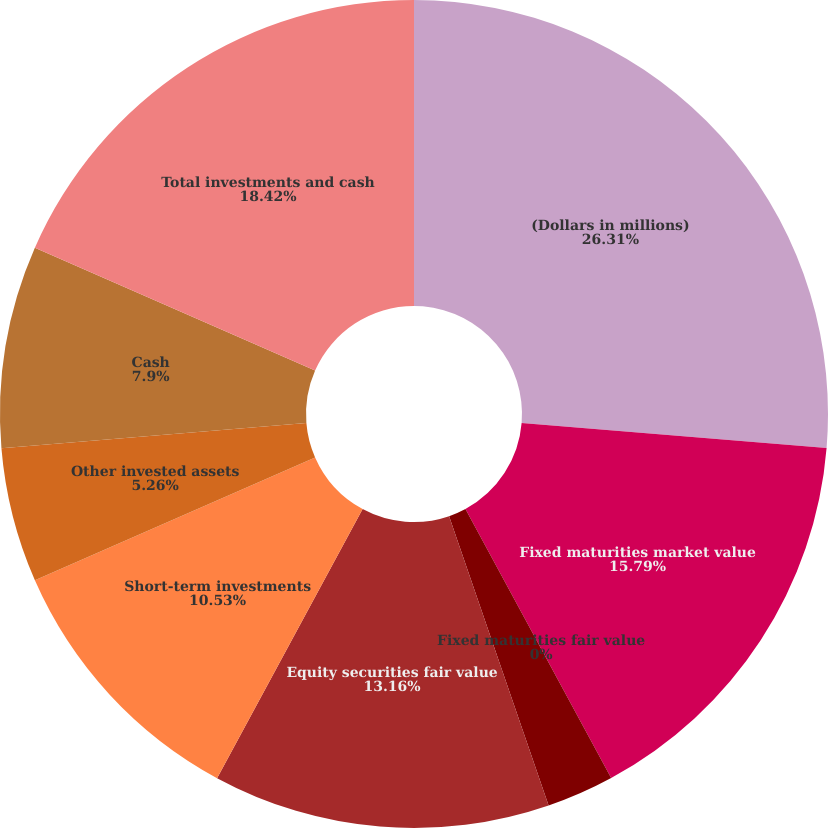Convert chart to OTSL. <chart><loc_0><loc_0><loc_500><loc_500><pie_chart><fcel>(Dollars in millions)<fcel>Fixed maturities market value<fcel>Fixed maturities fair value<fcel>Equity securities market value<fcel>Equity securities fair value<fcel>Short-term investments<fcel>Other invested assets<fcel>Cash<fcel>Total investments and cash<nl><fcel>26.31%<fcel>15.79%<fcel>0.0%<fcel>2.63%<fcel>13.16%<fcel>10.53%<fcel>5.26%<fcel>7.9%<fcel>18.42%<nl></chart> 